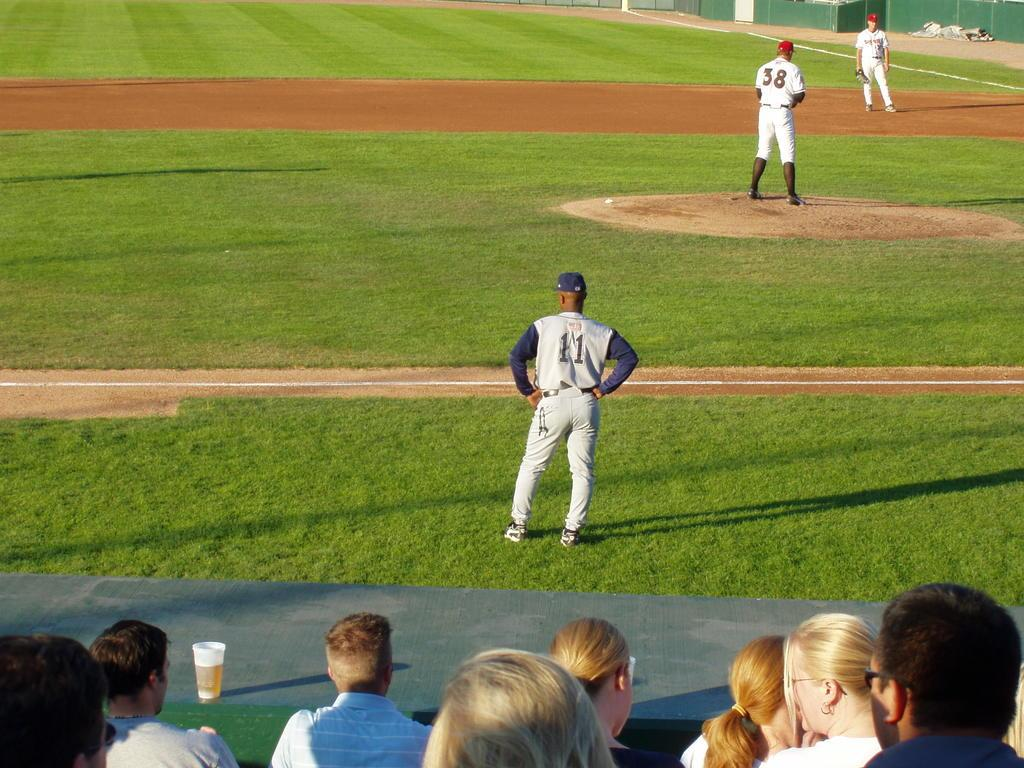<image>
Offer a succinct explanation of the picture presented. A third base coach wears the number 11 jersey as he watches the team play. 